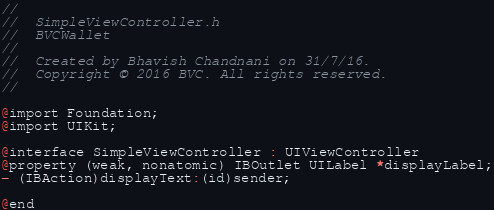Convert code to text. <code><loc_0><loc_0><loc_500><loc_500><_C_>//
//  SimpleViewController.h
//  BVCWallet
//
//  Created by Bhavish Chandnani on 31/7/16.
//  Copyright © 2016 BVC. All rights reserved.
//

@import Foundation;
@import UIKit;

@interface SimpleViewController : UIViewController
@property (weak, nonatomic) IBOutlet UILabel *displayLabel;
- (IBAction)displayText:(id)sender;

@end
</code> 